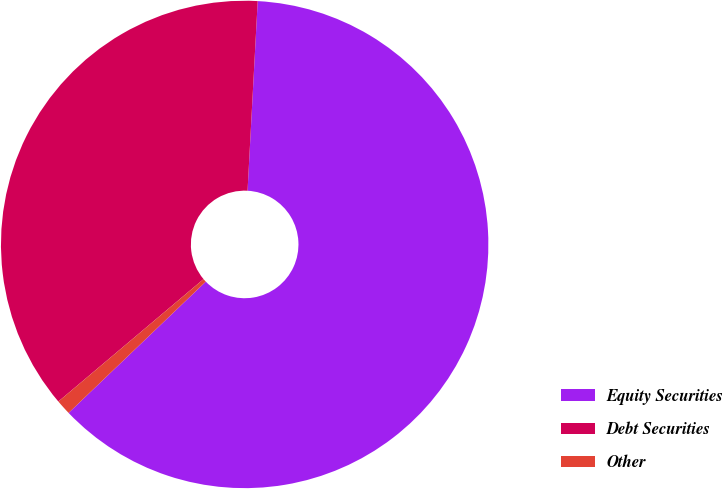Convert chart to OTSL. <chart><loc_0><loc_0><loc_500><loc_500><pie_chart><fcel>Equity Securities<fcel>Debt Securities<fcel>Other<nl><fcel>62.0%<fcel>37.0%<fcel>1.0%<nl></chart> 